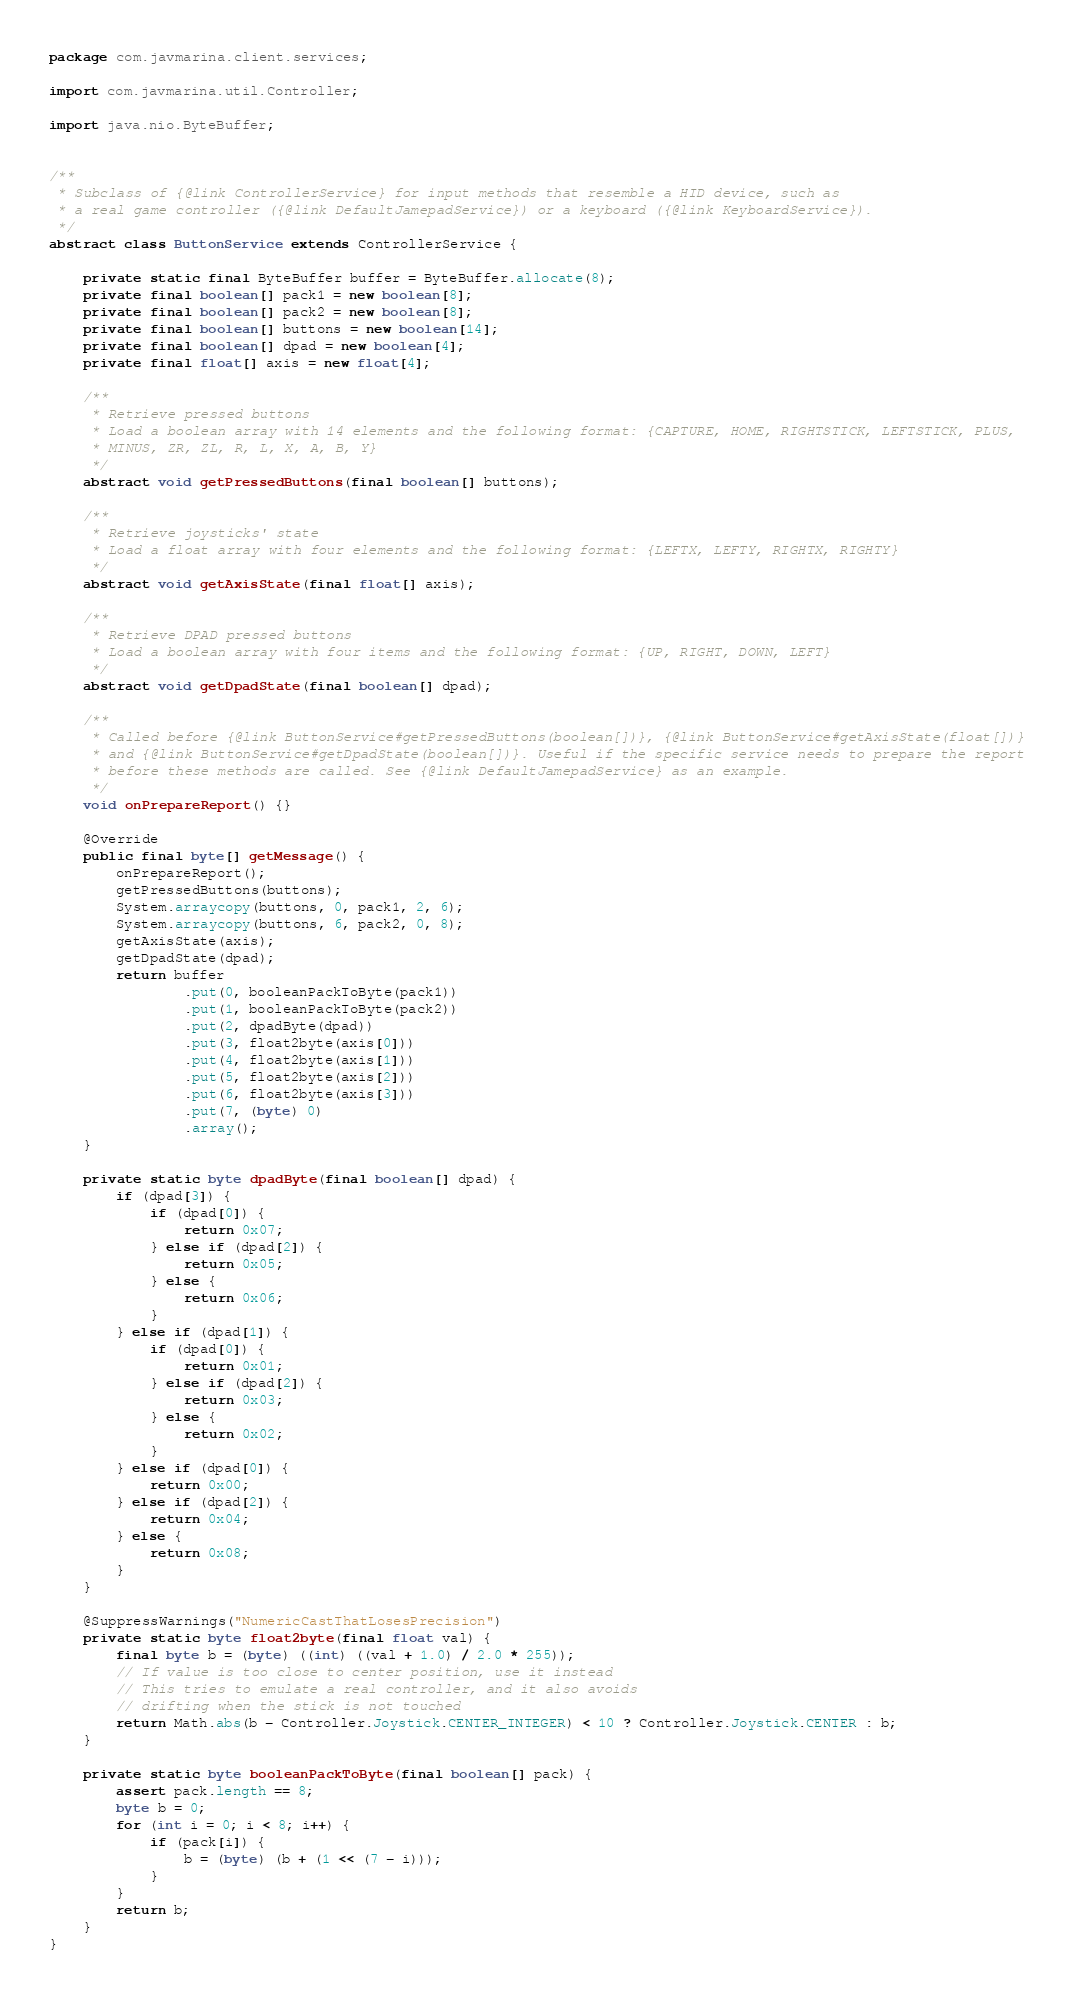Convert code to text. <code><loc_0><loc_0><loc_500><loc_500><_Java_>package com.javmarina.client.services;

import com.javmarina.util.Controller;

import java.nio.ByteBuffer;


/**
 * Subclass of {@link ControllerService} for input methods that resemble a HID device, such as
 * a real game controller ({@link DefaultJamepadService}) or a keyboard ({@link KeyboardService}).
 */
abstract class ButtonService extends ControllerService {

    private static final ByteBuffer buffer = ByteBuffer.allocate(8);
    private final boolean[] pack1 = new boolean[8];
    private final boolean[] pack2 = new boolean[8];
    private final boolean[] buttons = new boolean[14];
    private final boolean[] dpad = new boolean[4];
    private final float[] axis = new float[4];

    /**
     * Retrieve pressed buttons
     * Load a boolean array with 14 elements and the following format: {CAPTURE, HOME, RIGHTSTICK, LEFTSTICK, PLUS,
     * MINUS, ZR, ZL, R, L, X, A, B, Y}
     */
    abstract void getPressedButtons(final boolean[] buttons);

    /**
     * Retrieve joysticks' state
     * Load a float array with four elements and the following format: {LEFTX, LEFTY, RIGHTX, RIGHTY}
     */
    abstract void getAxisState(final float[] axis);

    /**
     * Retrieve DPAD pressed buttons
     * Load a boolean array with four items and the following format: {UP, RIGHT, DOWN, LEFT}
     */
    abstract void getDpadState(final boolean[] dpad);

    /**
     * Called before {@link ButtonService#getPressedButtons(boolean[])}, {@link ButtonService#getAxisState(float[])}
     * and {@link ButtonService#getDpadState(boolean[])}. Useful if the specific service needs to prepare the report
     * before these methods are called. See {@link DefaultJamepadService} as an example.
     */
    void onPrepareReport() {}

    @Override
    public final byte[] getMessage() {
        onPrepareReport();
        getPressedButtons(buttons);
        System.arraycopy(buttons, 0, pack1, 2, 6);
        System.arraycopy(buttons, 6, pack2, 0, 8);
        getAxisState(axis);
        getDpadState(dpad);
        return buffer
                .put(0, booleanPackToByte(pack1))
                .put(1, booleanPackToByte(pack2))
                .put(2, dpadByte(dpad))
                .put(3, float2byte(axis[0]))
                .put(4, float2byte(axis[1]))
                .put(5, float2byte(axis[2]))
                .put(6, float2byte(axis[3]))
                .put(7, (byte) 0)
                .array();
    }

    private static byte dpadByte(final boolean[] dpad) {
        if (dpad[3]) {
            if (dpad[0]) {
                return 0x07;
            } else if (dpad[2]) {
                return 0x05;
            } else {
                return 0x06;
            }
        } else if (dpad[1]) {
            if (dpad[0]) {
                return 0x01;
            } else if (dpad[2]) {
                return 0x03;
            } else {
                return 0x02;
            }
        } else if (dpad[0]) {
            return 0x00;
        } else if (dpad[2]) {
            return 0x04;
        } else {
            return 0x08;
        }
    }

    @SuppressWarnings("NumericCastThatLosesPrecision")
    private static byte float2byte(final float val) {
        final byte b = (byte) ((int) ((val + 1.0) / 2.0 * 255));
        // If value is too close to center position, use it instead
        // This tries to emulate a real controller, and it also avoids
        // drifting when the stick is not touched
        return Math.abs(b - Controller.Joystick.CENTER_INTEGER) < 10 ? Controller.Joystick.CENTER : b;
    }

    private static byte booleanPackToByte(final boolean[] pack) {
        assert pack.length == 8;
        byte b = 0;
        for (int i = 0; i < 8; i++) {
            if (pack[i]) {
                b = (byte) (b + (1 << (7 - i)));
            }
        }
        return b;
    }
}
</code> 